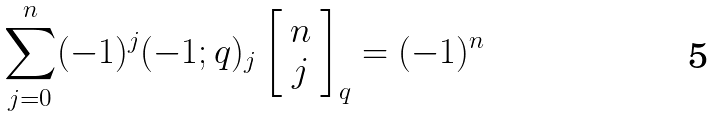Convert formula to latex. <formula><loc_0><loc_0><loc_500><loc_500>\sum _ { j = 0 } ^ { n } ( - 1 ) ^ { j } ( - 1 ; q ) _ { j } \left [ \begin{array} { c } n \\ j \end{array} \right ] _ { q } = ( - 1 ) ^ { n }</formula> 